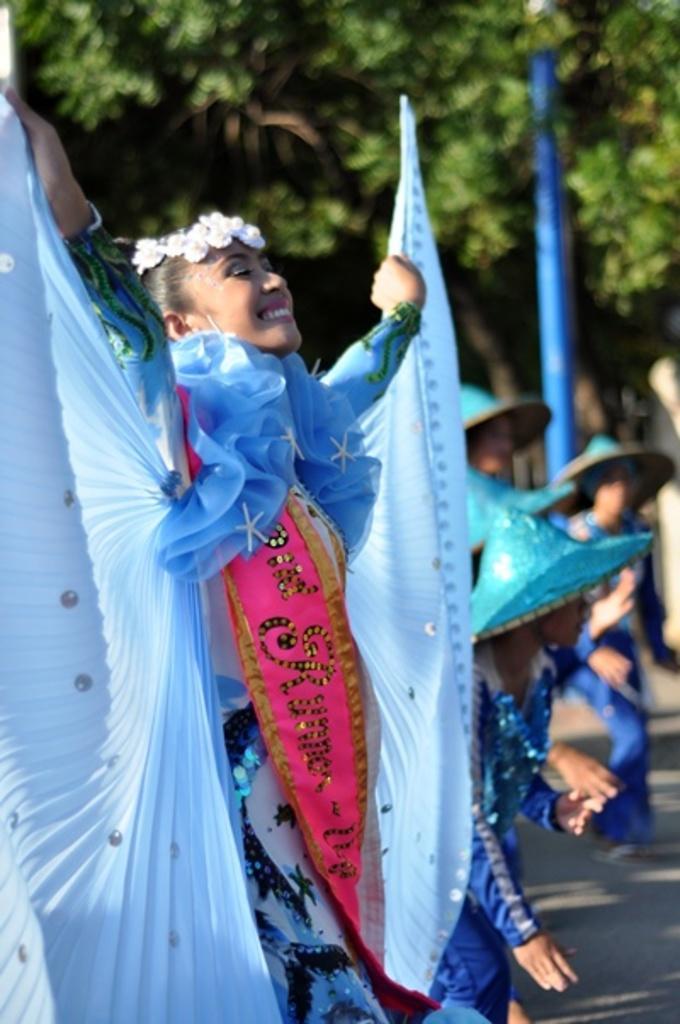In one or two sentences, can you explain what this image depicts? In this image we can see a group of women standing on the road. In the background there are trees and pole. 